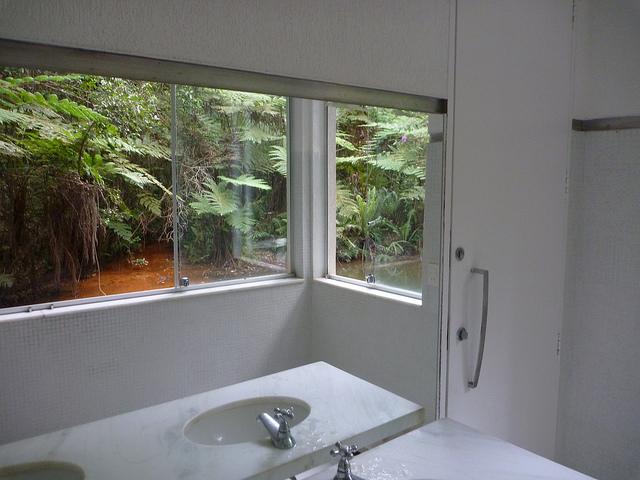What color is the countertop?
Quick response, please. White. How many windows are in the room?
Quick response, please. 2. Are there any screens on the windows?
Concise answer only. No. 